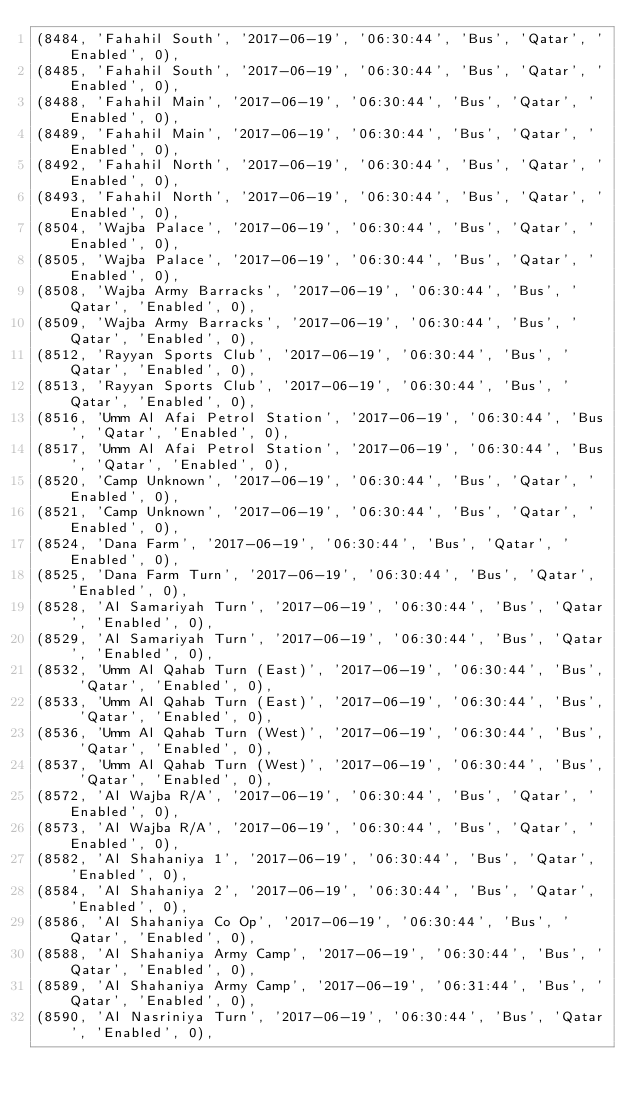Convert code to text. <code><loc_0><loc_0><loc_500><loc_500><_SQL_>(8484, 'Fahahil South', '2017-06-19', '06:30:44', 'Bus', 'Qatar', 'Enabled', 0),
(8485, 'Fahahil South', '2017-06-19', '06:30:44', 'Bus', 'Qatar', 'Enabled', 0),
(8488, 'Fahahil Main', '2017-06-19', '06:30:44', 'Bus', 'Qatar', 'Enabled', 0),
(8489, 'Fahahil Main', '2017-06-19', '06:30:44', 'Bus', 'Qatar', 'Enabled', 0),
(8492, 'Fahahil North', '2017-06-19', '06:30:44', 'Bus', 'Qatar', 'Enabled', 0),
(8493, 'Fahahil North', '2017-06-19', '06:30:44', 'Bus', 'Qatar', 'Enabled', 0),
(8504, 'Wajba Palace', '2017-06-19', '06:30:44', 'Bus', 'Qatar', 'Enabled', 0),
(8505, 'Wajba Palace', '2017-06-19', '06:30:44', 'Bus', 'Qatar', 'Enabled', 0),
(8508, 'Wajba Army Barracks', '2017-06-19', '06:30:44', 'Bus', 'Qatar', 'Enabled', 0),
(8509, 'Wajba Army Barracks', '2017-06-19', '06:30:44', 'Bus', 'Qatar', 'Enabled', 0),
(8512, 'Rayyan Sports Club', '2017-06-19', '06:30:44', 'Bus', 'Qatar', 'Enabled', 0),
(8513, 'Rayyan Sports Club', '2017-06-19', '06:30:44', 'Bus', 'Qatar', 'Enabled', 0),
(8516, 'Umm Al Afai Petrol Station', '2017-06-19', '06:30:44', 'Bus', 'Qatar', 'Enabled', 0),
(8517, 'Umm Al Afai Petrol Station', '2017-06-19', '06:30:44', 'Bus', 'Qatar', 'Enabled', 0),
(8520, 'Camp Unknown', '2017-06-19', '06:30:44', 'Bus', 'Qatar', 'Enabled', 0),
(8521, 'Camp Unknown', '2017-06-19', '06:30:44', 'Bus', 'Qatar', 'Enabled', 0),
(8524, 'Dana Farm', '2017-06-19', '06:30:44', 'Bus', 'Qatar', 'Enabled', 0),
(8525, 'Dana Farm Turn', '2017-06-19', '06:30:44', 'Bus', 'Qatar', 'Enabled', 0),
(8528, 'Al Samariyah Turn', '2017-06-19', '06:30:44', 'Bus', 'Qatar', 'Enabled', 0),
(8529, 'Al Samariyah Turn', '2017-06-19', '06:30:44', 'Bus', 'Qatar', 'Enabled', 0),
(8532, 'Umm Al Qahab Turn (East)', '2017-06-19', '06:30:44', 'Bus', 'Qatar', 'Enabled', 0),
(8533, 'Umm Al Qahab Turn (East)', '2017-06-19', '06:30:44', 'Bus', 'Qatar', 'Enabled', 0),
(8536, 'Umm Al Qahab Turn (West)', '2017-06-19', '06:30:44', 'Bus', 'Qatar', 'Enabled', 0),
(8537, 'Umm Al Qahab Turn (West)', '2017-06-19', '06:30:44', 'Bus', 'Qatar', 'Enabled', 0),
(8572, 'Al Wajba R/A', '2017-06-19', '06:30:44', 'Bus', 'Qatar', 'Enabled', 0),
(8573, 'Al Wajba R/A', '2017-06-19', '06:30:44', 'Bus', 'Qatar', 'Enabled', 0),
(8582, 'Al Shahaniya 1', '2017-06-19', '06:30:44', 'Bus', 'Qatar', 'Enabled', 0),
(8584, 'Al Shahaniya 2', '2017-06-19', '06:30:44', 'Bus', 'Qatar', 'Enabled', 0),
(8586, 'Al Shahaniya Co Op', '2017-06-19', '06:30:44', 'Bus', 'Qatar', 'Enabled', 0),
(8588, 'Al Shahaniya Army Camp', '2017-06-19', '06:30:44', 'Bus', 'Qatar', 'Enabled', 0),
(8589, 'Al Shahaniya Army Camp', '2017-06-19', '06:31:44', 'Bus', 'Qatar', 'Enabled', 0),
(8590, 'Al Nasriniya Turn', '2017-06-19', '06:30:44', 'Bus', 'Qatar', 'Enabled', 0),</code> 